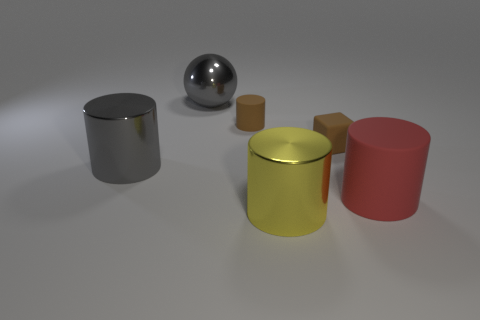Subtract 1 cylinders. How many cylinders are left? 3 Subtract all purple cylinders. Subtract all cyan balls. How many cylinders are left? 4 Add 1 rubber objects. How many objects exist? 7 Subtract all cylinders. How many objects are left? 2 Subtract 1 gray balls. How many objects are left? 5 Subtract all small yellow metallic blocks. Subtract all big matte cylinders. How many objects are left? 5 Add 3 tiny brown matte objects. How many tiny brown matte objects are left? 5 Add 4 brown metal things. How many brown metal things exist? 4 